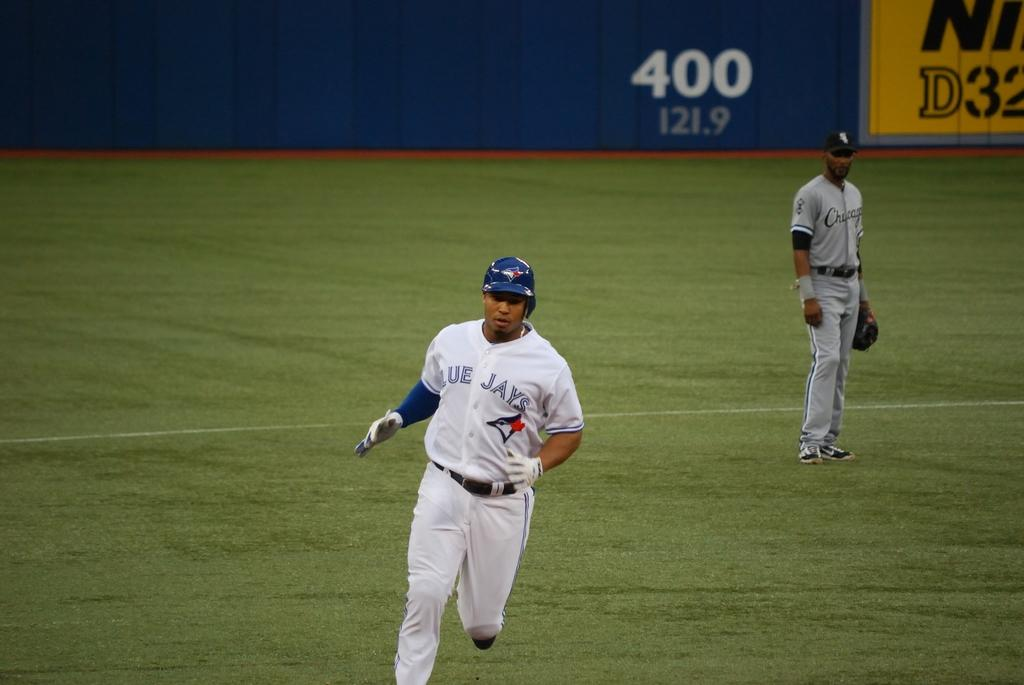<image>
Describe the image concisely. The number 400 is painted on the wall of a baseball park. 